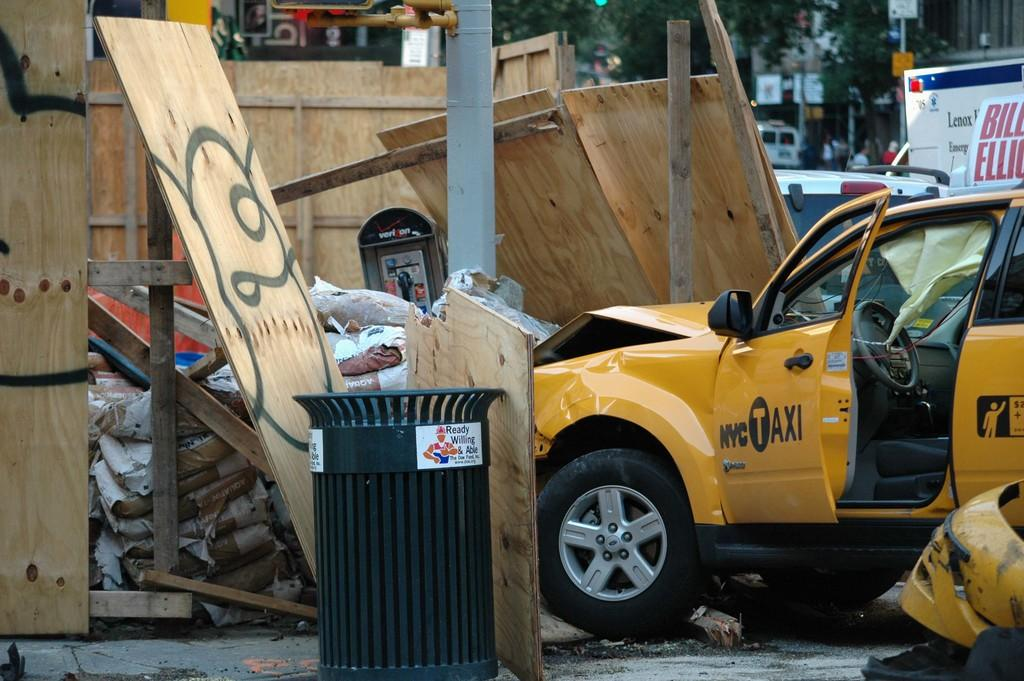<image>
Write a terse but informative summary of the picture. A NYC taxi has crashed into a wall and some trash. 